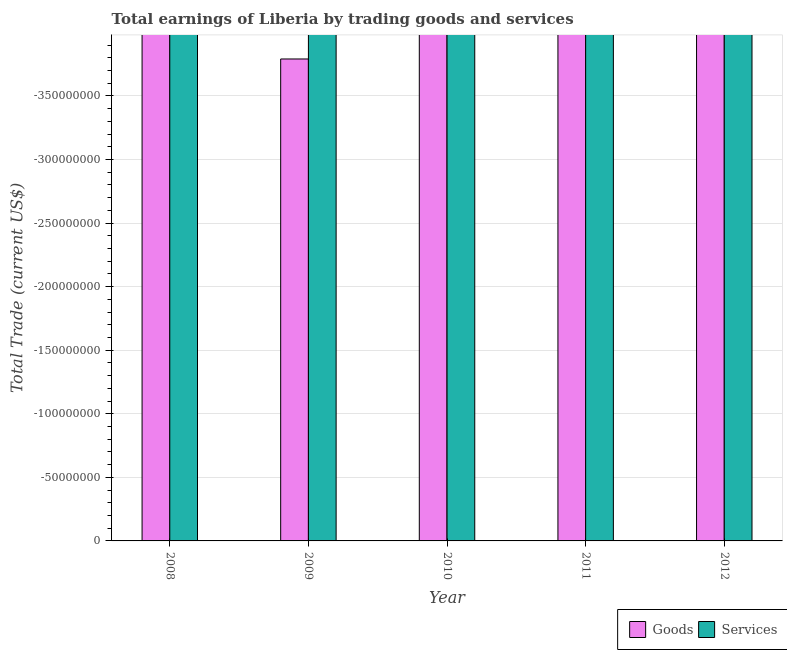Are the number of bars per tick equal to the number of legend labels?
Ensure brevity in your answer.  No. How many bars are there on the 4th tick from the left?
Ensure brevity in your answer.  0. How many bars are there on the 4th tick from the right?
Make the answer very short. 0. What is the label of the 4th group of bars from the left?
Offer a very short reply. 2011. What is the amount earned by trading services in 2011?
Your answer should be very brief. 0. What is the difference between the amount earned by trading services in 2008 and the amount earned by trading goods in 2010?
Your answer should be very brief. 0. What is the average amount earned by trading goods per year?
Provide a short and direct response. 0. In how many years, is the amount earned by trading goods greater than -130000000 US$?
Make the answer very short. 0. In how many years, is the amount earned by trading services greater than the average amount earned by trading services taken over all years?
Your response must be concise. 0. How many bars are there?
Provide a short and direct response. 0. Are all the bars in the graph horizontal?
Ensure brevity in your answer.  No. How many years are there in the graph?
Your response must be concise. 5. What is the difference between two consecutive major ticks on the Y-axis?
Offer a very short reply. 5.00e+07. Does the graph contain any zero values?
Ensure brevity in your answer.  Yes. Does the graph contain grids?
Offer a terse response. Yes. How are the legend labels stacked?
Keep it short and to the point. Horizontal. What is the title of the graph?
Ensure brevity in your answer.  Total earnings of Liberia by trading goods and services. What is the label or title of the X-axis?
Offer a very short reply. Year. What is the label or title of the Y-axis?
Provide a short and direct response. Total Trade (current US$). What is the Total Trade (current US$) of Goods in 2011?
Make the answer very short. 0. What is the Total Trade (current US$) of Services in 2011?
Give a very brief answer. 0. What is the Total Trade (current US$) of Goods in 2012?
Give a very brief answer. 0. What is the total Total Trade (current US$) of Goods in the graph?
Your answer should be compact. 0. What is the average Total Trade (current US$) in Services per year?
Give a very brief answer. 0. 